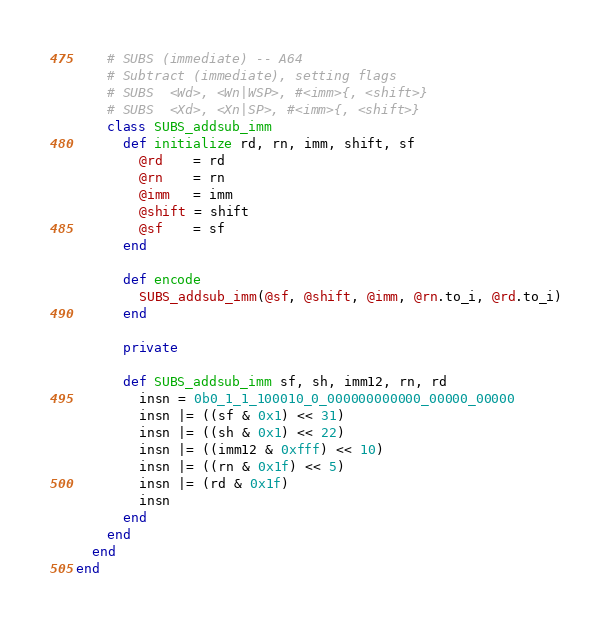Convert code to text. <code><loc_0><loc_0><loc_500><loc_500><_Ruby_>    # SUBS (immediate) -- A64
    # Subtract (immediate), setting flags
    # SUBS  <Wd>, <Wn|WSP>, #<imm>{, <shift>}
    # SUBS  <Xd>, <Xn|SP>, #<imm>{, <shift>}
    class SUBS_addsub_imm
      def initialize rd, rn, imm, shift, sf
        @rd    = rd
        @rn    = rn
        @imm   = imm
        @shift = shift
        @sf    = sf
      end

      def encode
        SUBS_addsub_imm(@sf, @shift, @imm, @rn.to_i, @rd.to_i)
      end

      private

      def SUBS_addsub_imm sf, sh, imm12, rn, rd
        insn = 0b0_1_1_100010_0_000000000000_00000_00000
        insn |= ((sf & 0x1) << 31)
        insn |= ((sh & 0x1) << 22)
        insn |= ((imm12 & 0xfff) << 10)
        insn |= ((rn & 0x1f) << 5)
        insn |= (rd & 0x1f)
        insn
      end
    end
  end
end
</code> 